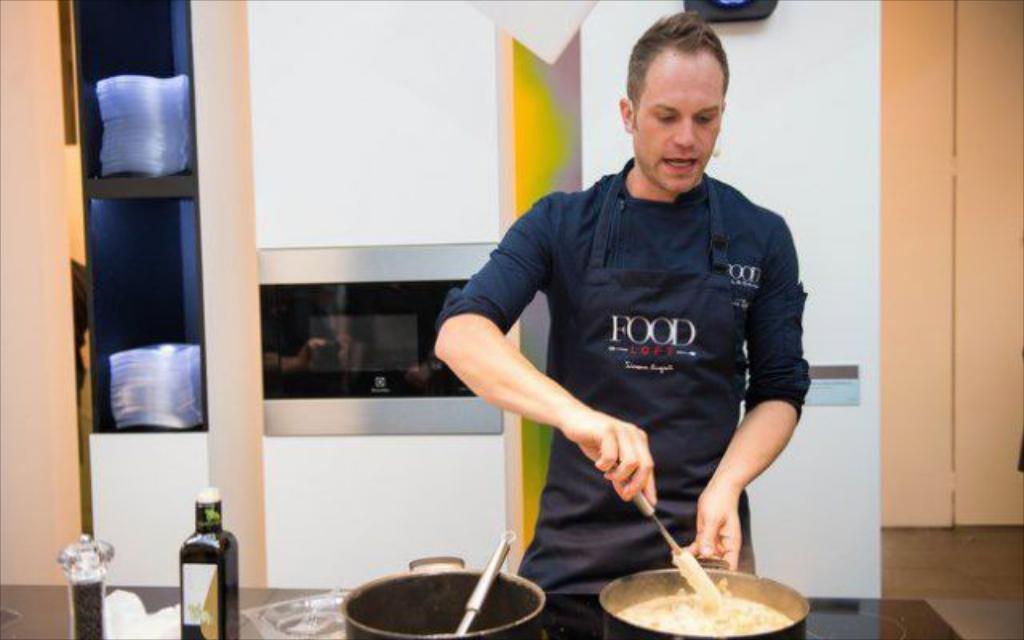Please provide a concise description of this image. In this image I can see some objects on the table. I can see a person standing. In the background, I can see some objects in the shelf. I can also see the wall. 